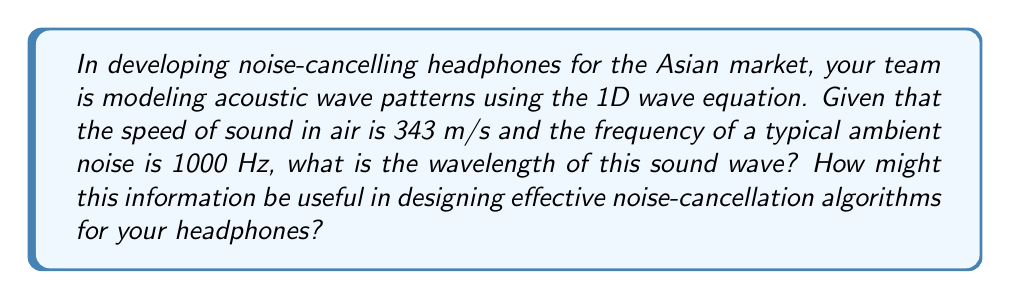Can you solve this math problem? To solve this problem, we'll use the wave equation relationship between wave speed, frequency, and wavelength:

$$c = f\lambda$$

Where:
$c$ = wave speed (m/s)
$f$ = frequency (Hz)
$\lambda$ = wavelength (m)

Given:
$c = 343$ m/s
$f = 1000$ Hz

Step 1: Rearrange the equation to solve for wavelength:
$$\lambda = \frac{c}{f}$$

Step 2: Substitute the known values:
$$\lambda = \frac{343 \text{ m/s}}{1000 \text{ Hz}}$$

Step 3: Calculate the wavelength:
$$\lambda = 0.343 \text{ m}$$

This wavelength information is crucial for designing effective noise-cancellation algorithms:

1. Microphone placement: Knowing the wavelength helps determine optimal positions for noise-sensing microphones in the headphones.

2. Filter design: The wavelength informs the design of digital filters used in the noise-cancellation process.

3. Phase adjustment: Understanding the wavelength aids in accurately adjusting the phase of the cancellation signal to match the incoming noise.

4. Frequency response: This information helps in tuning the frequency response of the noise-cancellation system to be most effective at common noise frequencies.

5. Enclosure design: The wavelength can inform the physical design of the headphone enclosure to optimize noise isolation.

By considering these factors, your company can develop noise-cancelling headphones that are particularly effective against common ambient noises in Asian urban environments, potentially giving you a competitive edge in the market.
Answer: $\lambda = 0.343 \text{ m}$ 